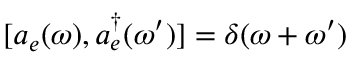Convert formula to latex. <formula><loc_0><loc_0><loc_500><loc_500>[ a _ { e } ( \omega ) , a _ { e } ^ { \dagger } ( \omega ^ { \prime } ) ] = \delta ( \omega + \omega ^ { \prime } )</formula> 